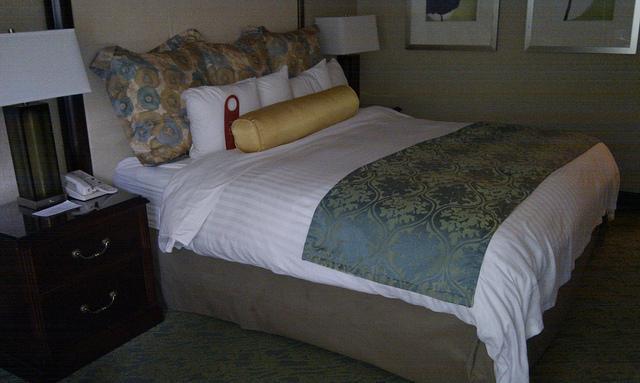How many pillows are on the bed?
Give a very brief answer. 8. How many pictures on the wall?
Give a very brief answer. 2. 